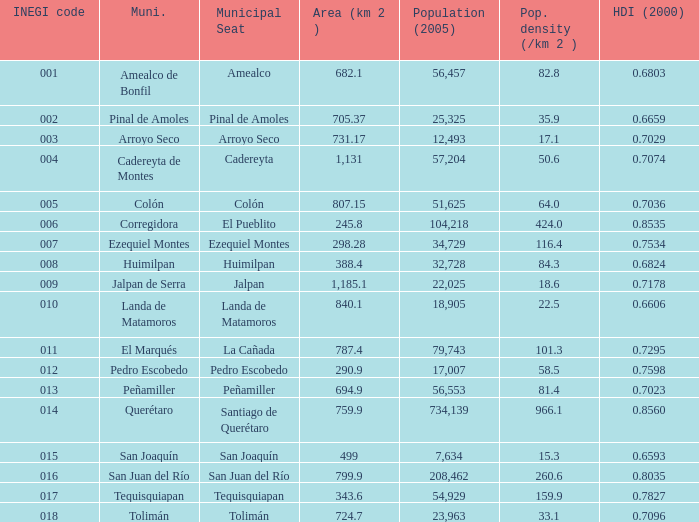Which Area (km 2 )has a Population (2005) of 57,204, and a Human Development Index (2000) smaller than 0.7074? 0.0. 